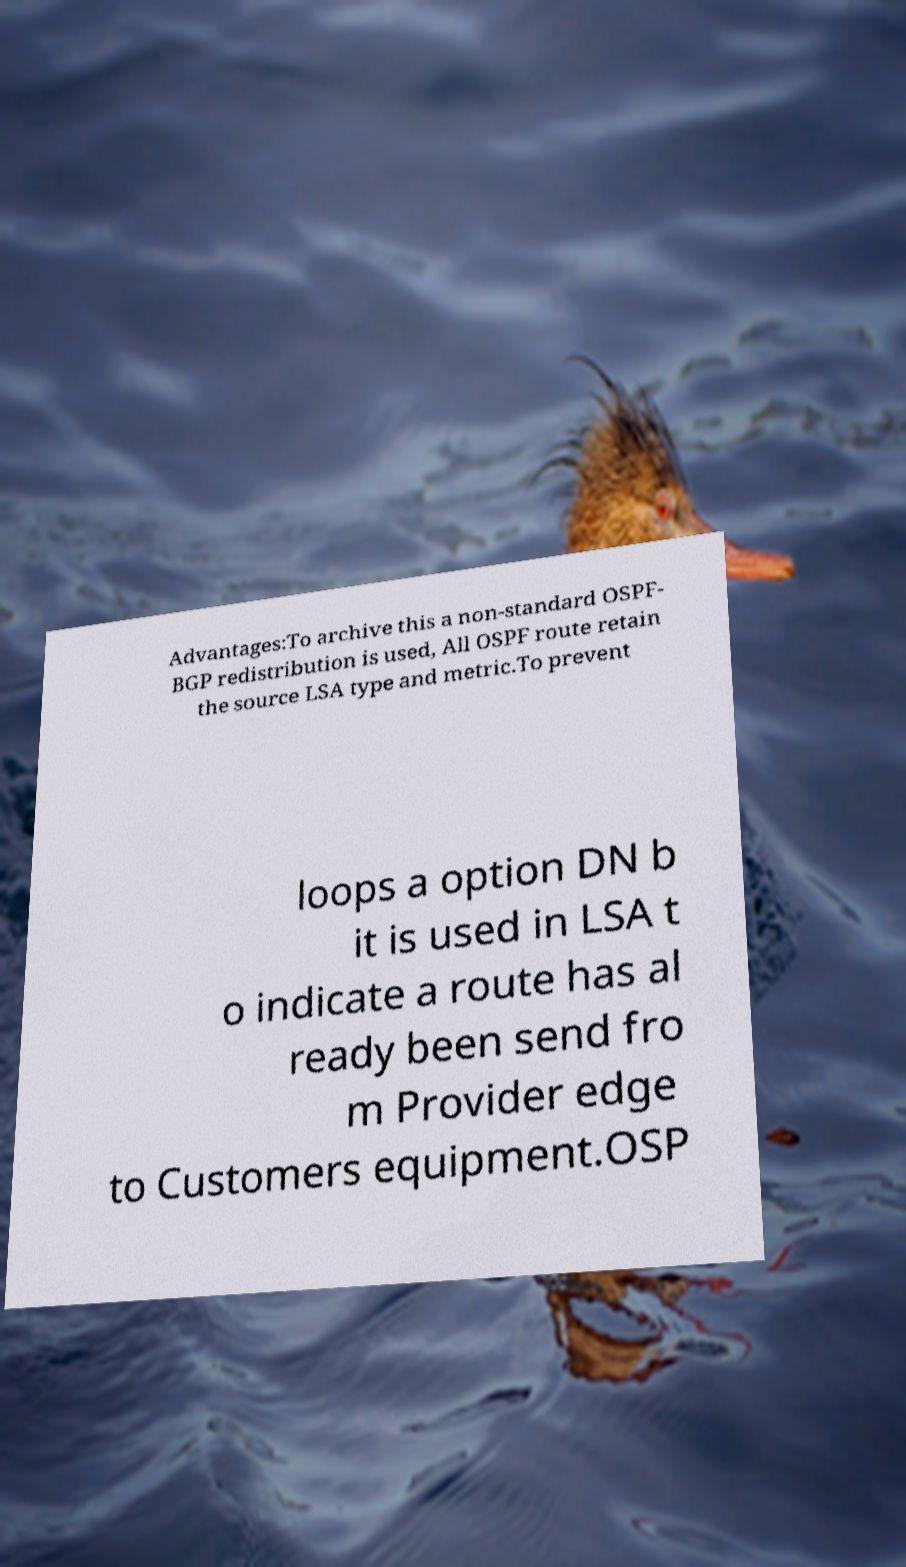Could you assist in decoding the text presented in this image and type it out clearly? Advantages:To archive this a non-standard OSPF- BGP redistribution is used, All OSPF route retain the source LSA type and metric.To prevent loops a option DN b it is used in LSA t o indicate a route has al ready been send fro m Provider edge to Customers equipment.OSP 